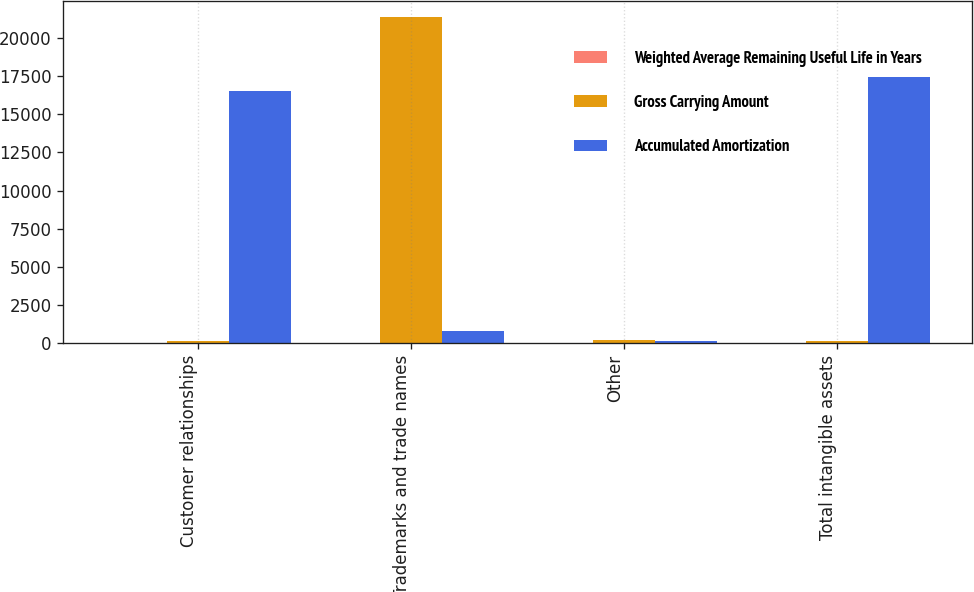Convert chart to OTSL. <chart><loc_0><loc_0><loc_500><loc_500><stacked_bar_chart><ecel><fcel>Customer relationships<fcel>Trademarks and trade names<fcel>Other<fcel>Total intangible assets<nl><fcel>Weighted Average Remaining Useful Life in Years<fcel>15.4<fcel>14.7<fcel>3<fcel>15.4<nl><fcel>Gross Carrying Amount<fcel>164.5<fcel>21370<fcel>220<fcel>164.5<nl><fcel>Accumulated Amortization<fcel>16509<fcel>794<fcel>109<fcel>17412<nl></chart> 